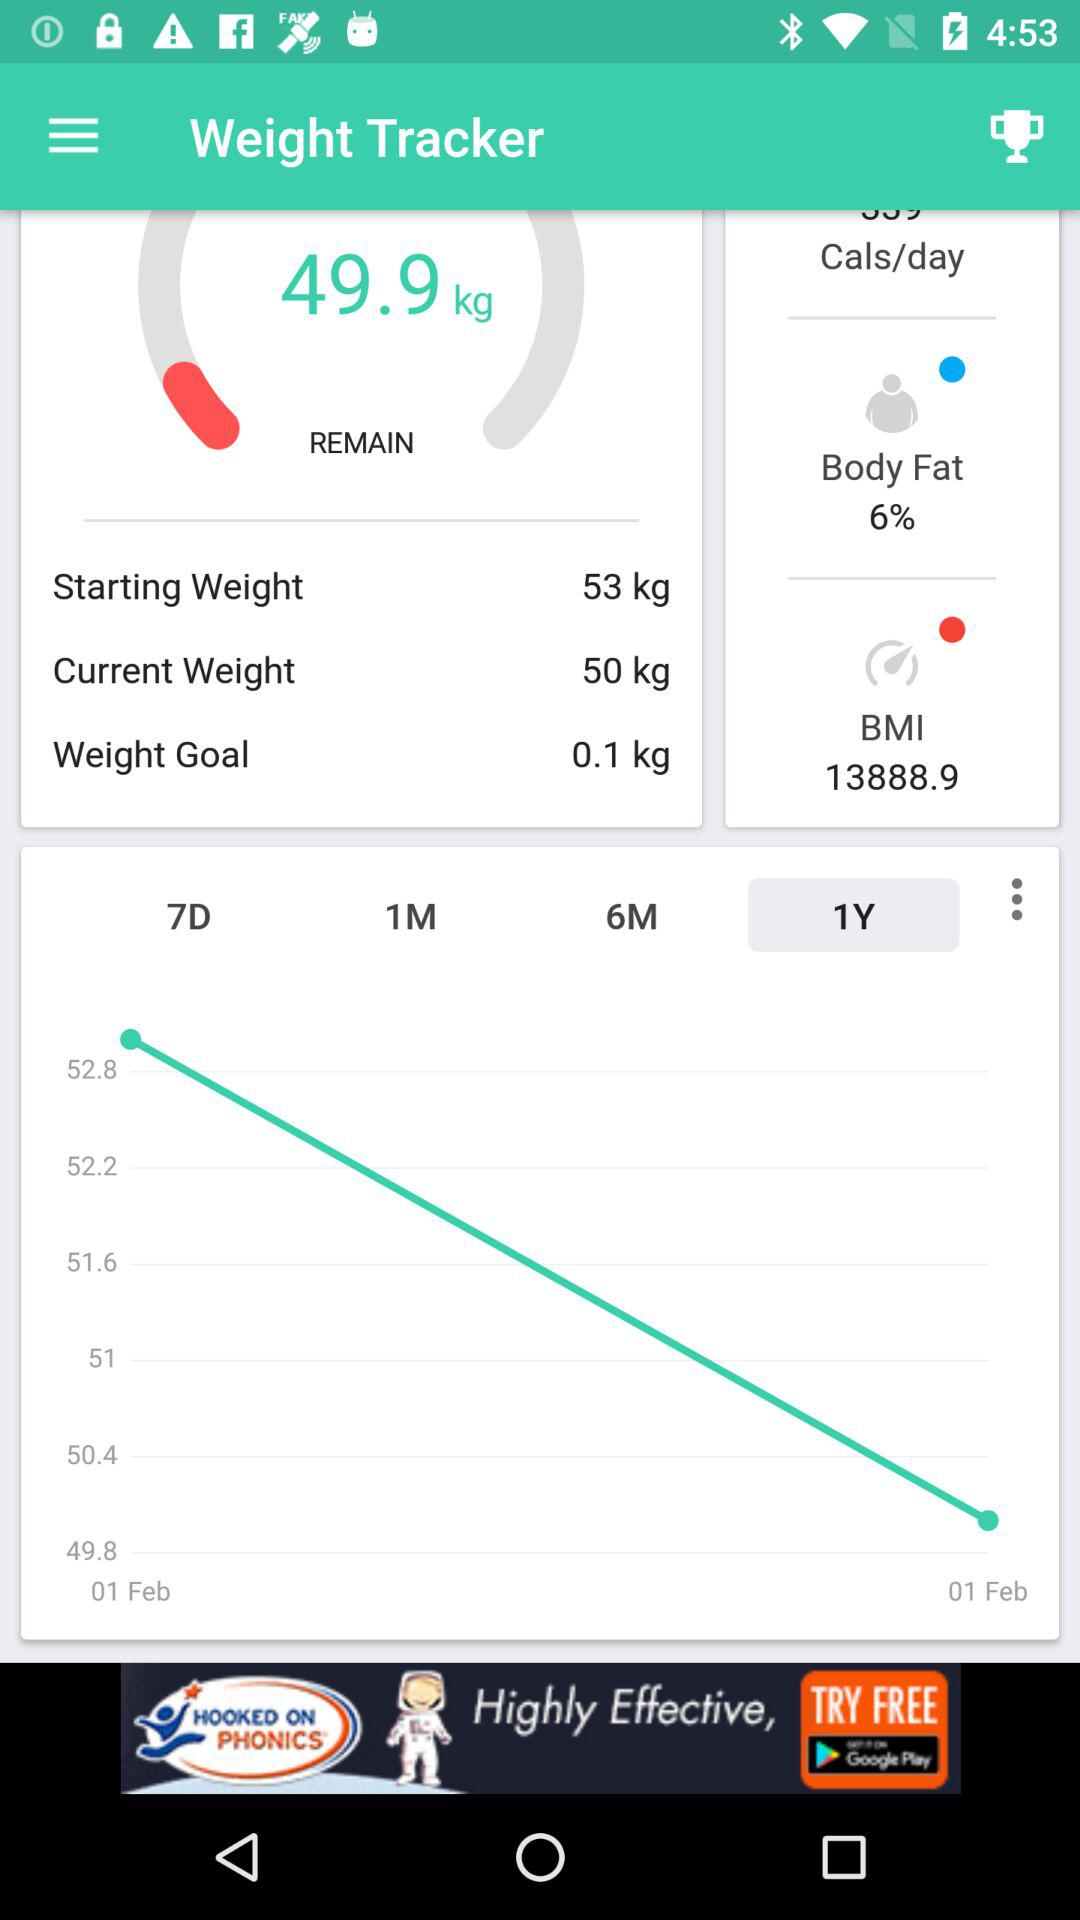Which weight is selected for the weight goal? The weight selected for the weight goal is 0.1 kg. 